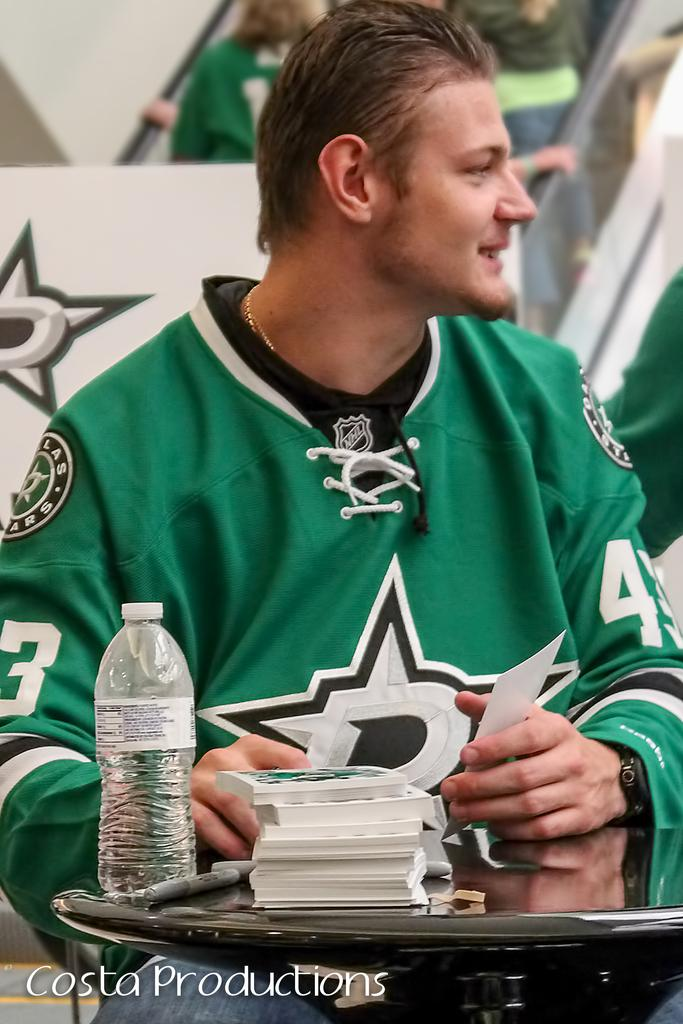What is the person sitting on in the image? There is a person sitting on a chair in the image. What is the person wearing? The person is wearing a green t-shirt. What can be seen on the table in front of the person? There is a bottle and books on the table. How many other persons are visible in the image? There are other persons visible behind the person sitting on the chair. What can be seen in the background of the image? There is an escalator and a board in the background. What type of industry is depicted in the image? There is no industry depicted in the image; it features a person sitting on a chair, a table with objects, and other persons in the background. What date is shown on the calendar in the image? There is no calendar present in the image. 